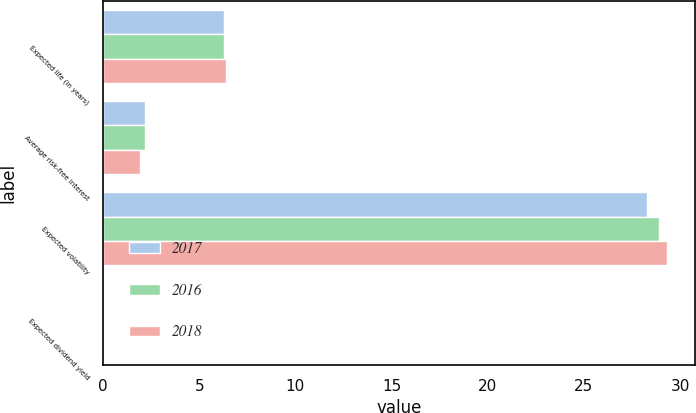Convert chart to OTSL. <chart><loc_0><loc_0><loc_500><loc_500><stacked_bar_chart><ecel><fcel>Expected life (in years)<fcel>Average risk-free interest<fcel>Expected volatility<fcel>Expected dividend yield<nl><fcel>2017<fcel>6.3<fcel>2.2<fcel>28.3<fcel>0<nl><fcel>2016<fcel>6.3<fcel>2.2<fcel>28.9<fcel>0<nl><fcel>2018<fcel>6.4<fcel>1.9<fcel>29.3<fcel>0<nl></chart> 